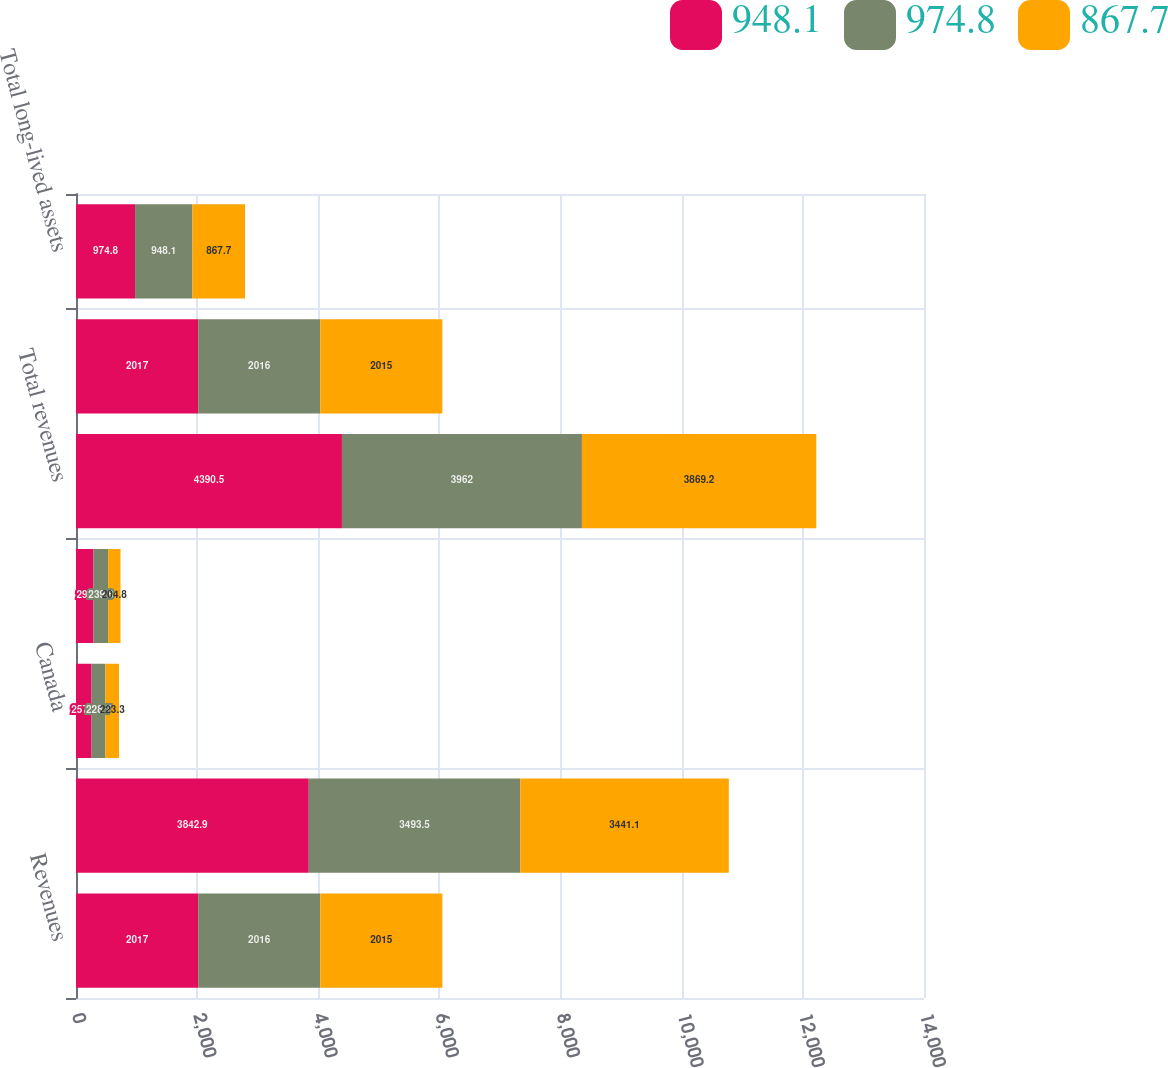<chart> <loc_0><loc_0><loc_500><loc_500><stacked_bar_chart><ecel><fcel>Revenues<fcel>United States<fcel>Canada<fcel>Other foreign countries<fcel>Total revenues<fcel>Long-Lived Assets<fcel>Total long-lived assets<nl><fcel>948.1<fcel>2017<fcel>3842.9<fcel>257.6<fcel>290<fcel>4390.5<fcel>2017<fcel>974.8<nl><fcel>974.8<fcel>2016<fcel>3493.5<fcel>228.7<fcel>239.8<fcel>3962<fcel>2016<fcel>948.1<nl><fcel>867.7<fcel>2015<fcel>3441.1<fcel>223.3<fcel>204.8<fcel>3869.2<fcel>2015<fcel>867.7<nl></chart> 